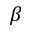<formula> <loc_0><loc_0><loc_500><loc_500>\beta</formula> 